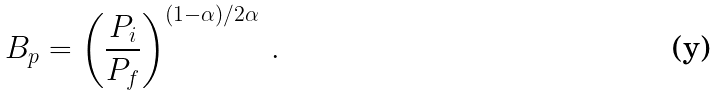Convert formula to latex. <formula><loc_0><loc_0><loc_500><loc_500>B _ { p } = \left ( \frac { P _ { i } } { P _ { f } } \right ) ^ { ( 1 - \alpha ) / 2 \alpha } \, .</formula> 